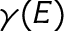<formula> <loc_0><loc_0><loc_500><loc_500>\gamma ( E )</formula> 